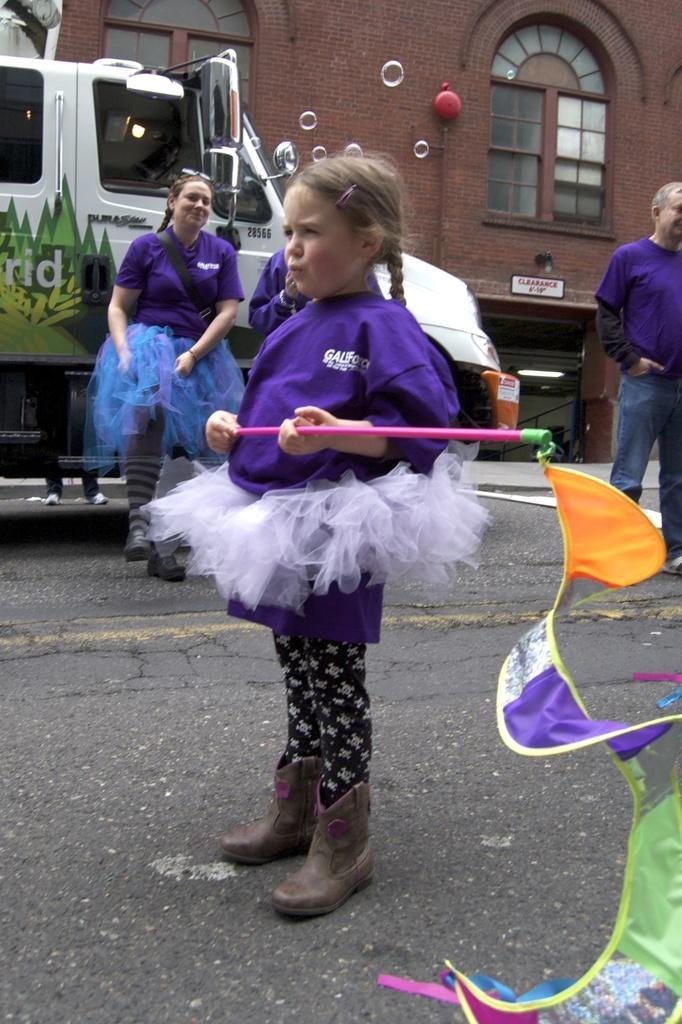How would you summarize this image in a sentence or two? There is a small girl standing in the foreground holding a stick of the colorful flag, there are people, vehicle, building, windows and a small board in the background area. 